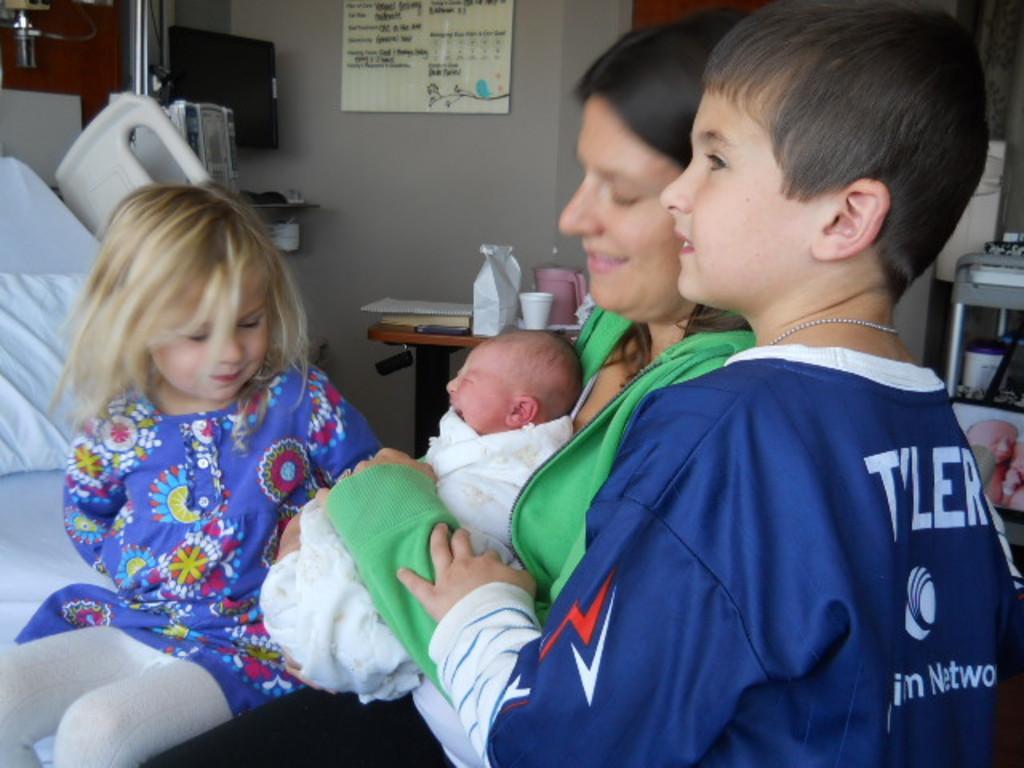In one or two sentences, can you explain what this image depicts? In this image I can see few people sitting on the bed and wearing different color dresses. Back I can see cups,books and few objects on the table. The frame is attached to the wall. I can see a system,wall and few objects. 